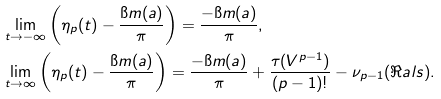Convert formula to latex. <formula><loc_0><loc_0><loc_500><loc_500>& \lim _ { t \rightarrow - \infty } \left ( \eta _ { p } ( t ) - \frac { \i m ( a ) } { \pi } \right ) = \frac { - \i m ( a ) } { \pi } , \\ & \lim _ { t \rightarrow \infty } \left ( \eta _ { p } ( t ) - \frac { \i m ( a ) } { \pi } \right ) = \frac { - \i m ( a ) } { \pi } + \frac { \tau ( V ^ { p - 1 } ) } { ( p - 1 ) ! } - \nu _ { p - 1 } ( \Re a l s ) .</formula> 